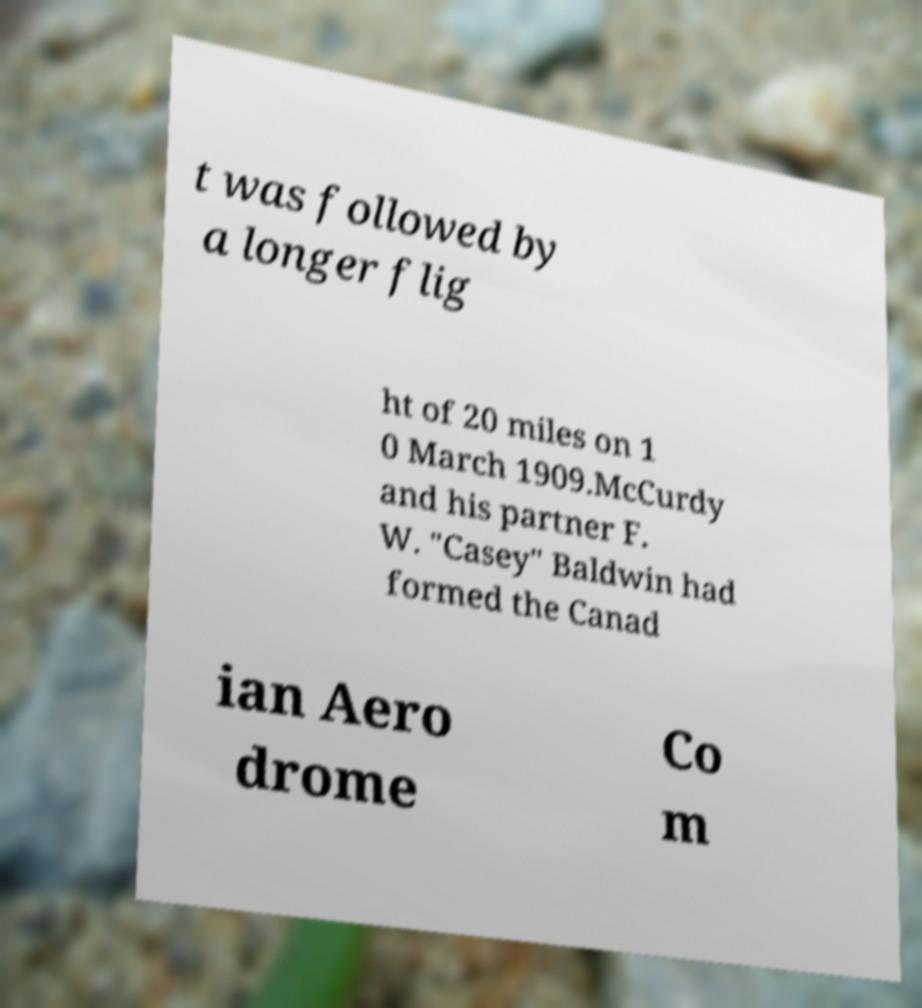Could you extract and type out the text from this image? t was followed by a longer flig ht of 20 miles on 1 0 March 1909.McCurdy and his partner F. W. "Casey" Baldwin had formed the Canad ian Aero drome Co m 